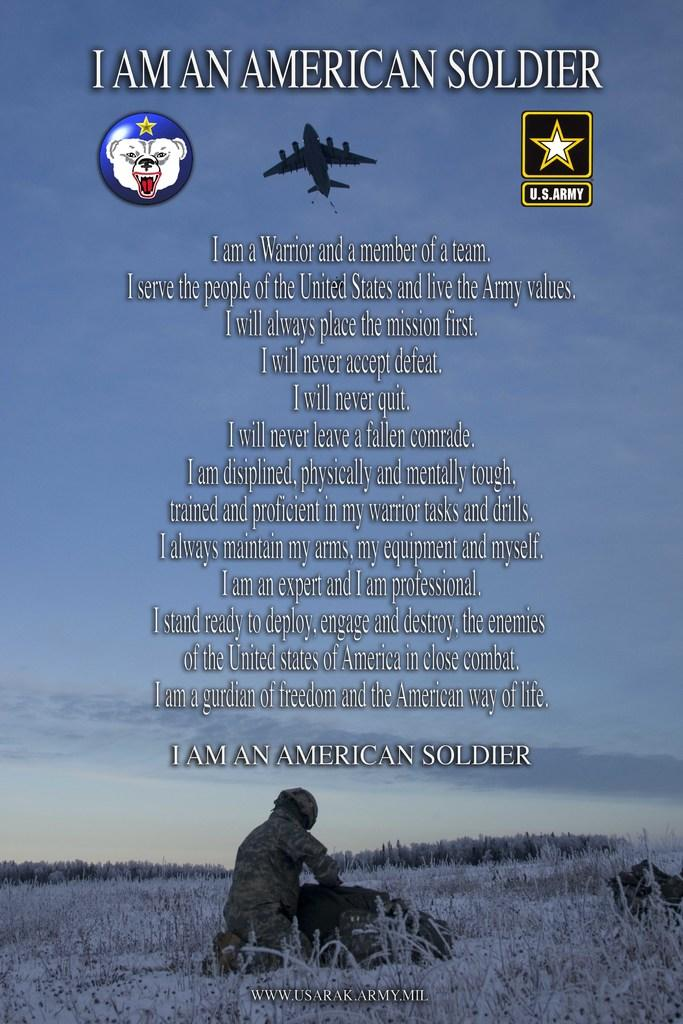<image>
Write a terse but informative summary of the picture. The poster shows a written pledge titled "I am an American Soldier". 